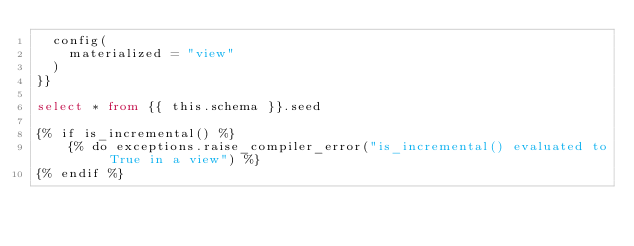<code> <loc_0><loc_0><loc_500><loc_500><_SQL_>  config(
    materialized = "view"
  )
}}

select * from {{ this.schema }}.seed

{% if is_incremental() %}
    {% do exceptions.raise_compiler_error("is_incremental() evaluated to True in a view") %}
{% endif %}
</code> 